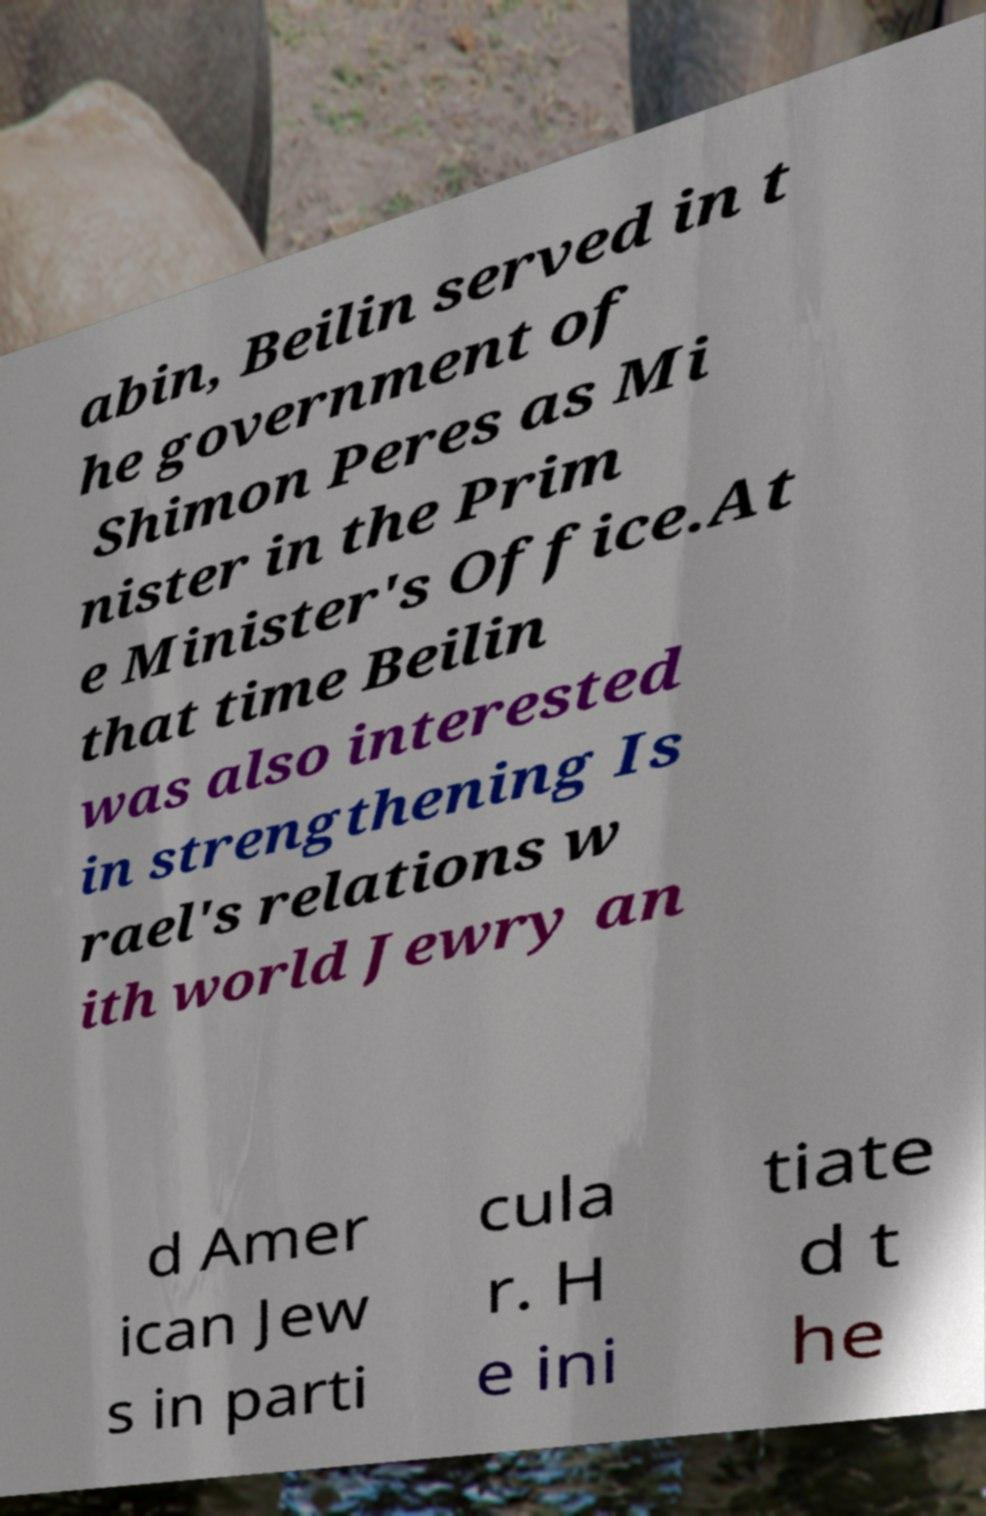For documentation purposes, I need the text within this image transcribed. Could you provide that? abin, Beilin served in t he government of Shimon Peres as Mi nister in the Prim e Minister's Office.At that time Beilin was also interested in strengthening Is rael's relations w ith world Jewry an d Amer ican Jew s in parti cula r. H e ini tiate d t he 